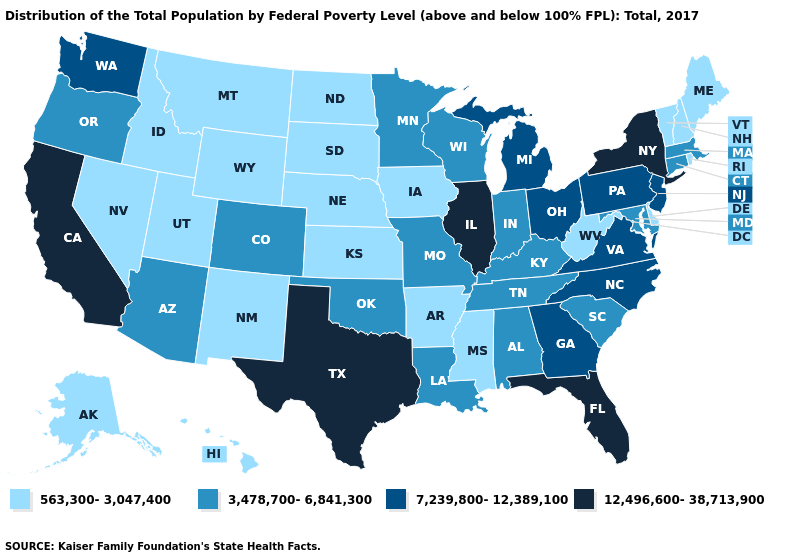What is the value of Hawaii?
Short answer required. 563,300-3,047,400. What is the value of Alabama?
Answer briefly. 3,478,700-6,841,300. What is the highest value in the South ?
Concise answer only. 12,496,600-38,713,900. Does California have the highest value in the West?
Write a very short answer. Yes. Does the first symbol in the legend represent the smallest category?
Quick response, please. Yes. Name the states that have a value in the range 3,478,700-6,841,300?
Short answer required. Alabama, Arizona, Colorado, Connecticut, Indiana, Kentucky, Louisiana, Maryland, Massachusetts, Minnesota, Missouri, Oklahoma, Oregon, South Carolina, Tennessee, Wisconsin. What is the value of Maryland?
Quick response, please. 3,478,700-6,841,300. What is the lowest value in the USA?
Concise answer only. 563,300-3,047,400. Name the states that have a value in the range 563,300-3,047,400?
Answer briefly. Alaska, Arkansas, Delaware, Hawaii, Idaho, Iowa, Kansas, Maine, Mississippi, Montana, Nebraska, Nevada, New Hampshire, New Mexico, North Dakota, Rhode Island, South Dakota, Utah, Vermont, West Virginia, Wyoming. Name the states that have a value in the range 3,478,700-6,841,300?
Give a very brief answer. Alabama, Arizona, Colorado, Connecticut, Indiana, Kentucky, Louisiana, Maryland, Massachusetts, Minnesota, Missouri, Oklahoma, Oregon, South Carolina, Tennessee, Wisconsin. What is the value of Florida?
Quick response, please. 12,496,600-38,713,900. What is the highest value in states that border South Dakota?
Be succinct. 3,478,700-6,841,300. Name the states that have a value in the range 7,239,800-12,389,100?
Short answer required. Georgia, Michigan, New Jersey, North Carolina, Ohio, Pennsylvania, Virginia, Washington. Name the states that have a value in the range 12,496,600-38,713,900?
Short answer required. California, Florida, Illinois, New York, Texas. What is the value of Oklahoma?
Answer briefly. 3,478,700-6,841,300. 